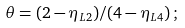Convert formula to latex. <formula><loc_0><loc_0><loc_500><loc_500>\theta = ( 2 - \eta _ { L 2 } ) / ( 4 - \eta _ { L 4 } ) \, ;</formula> 